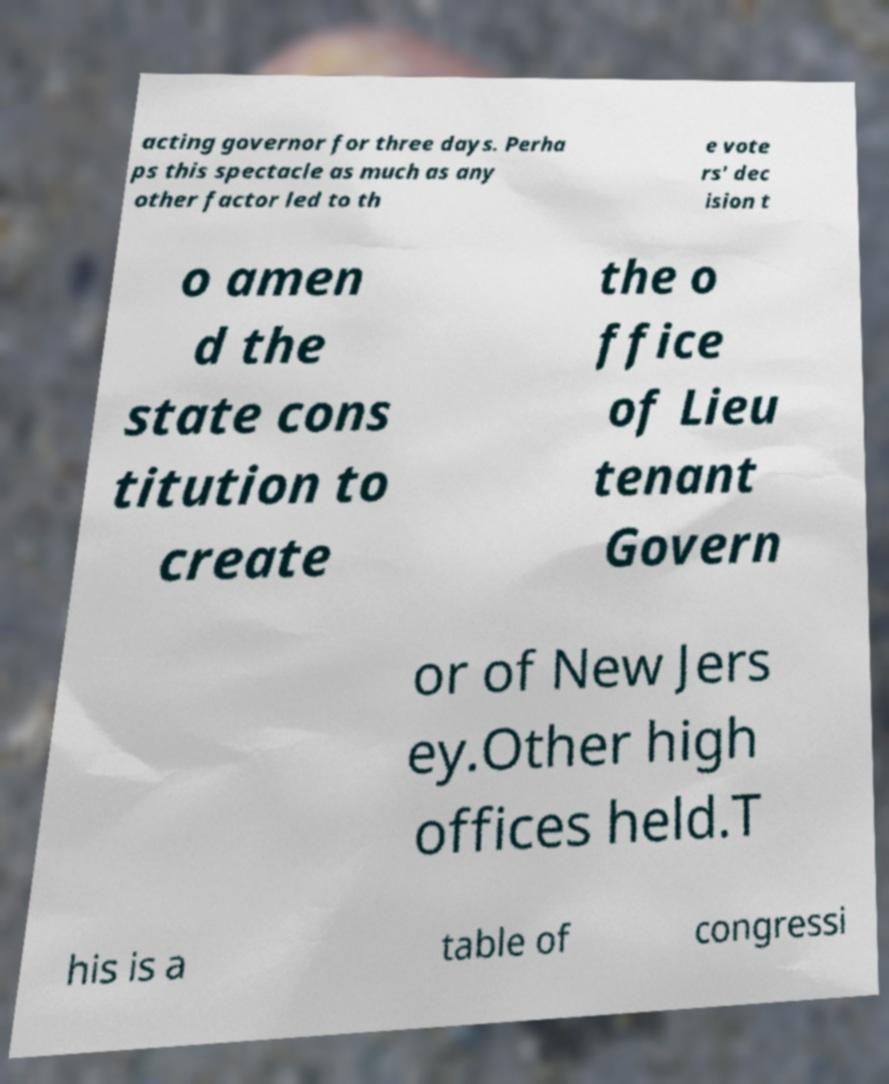Could you extract and type out the text from this image? acting governor for three days. Perha ps this spectacle as much as any other factor led to th e vote rs' dec ision t o amen d the state cons titution to create the o ffice of Lieu tenant Govern or of New Jers ey.Other high offices held.T his is a table of congressi 